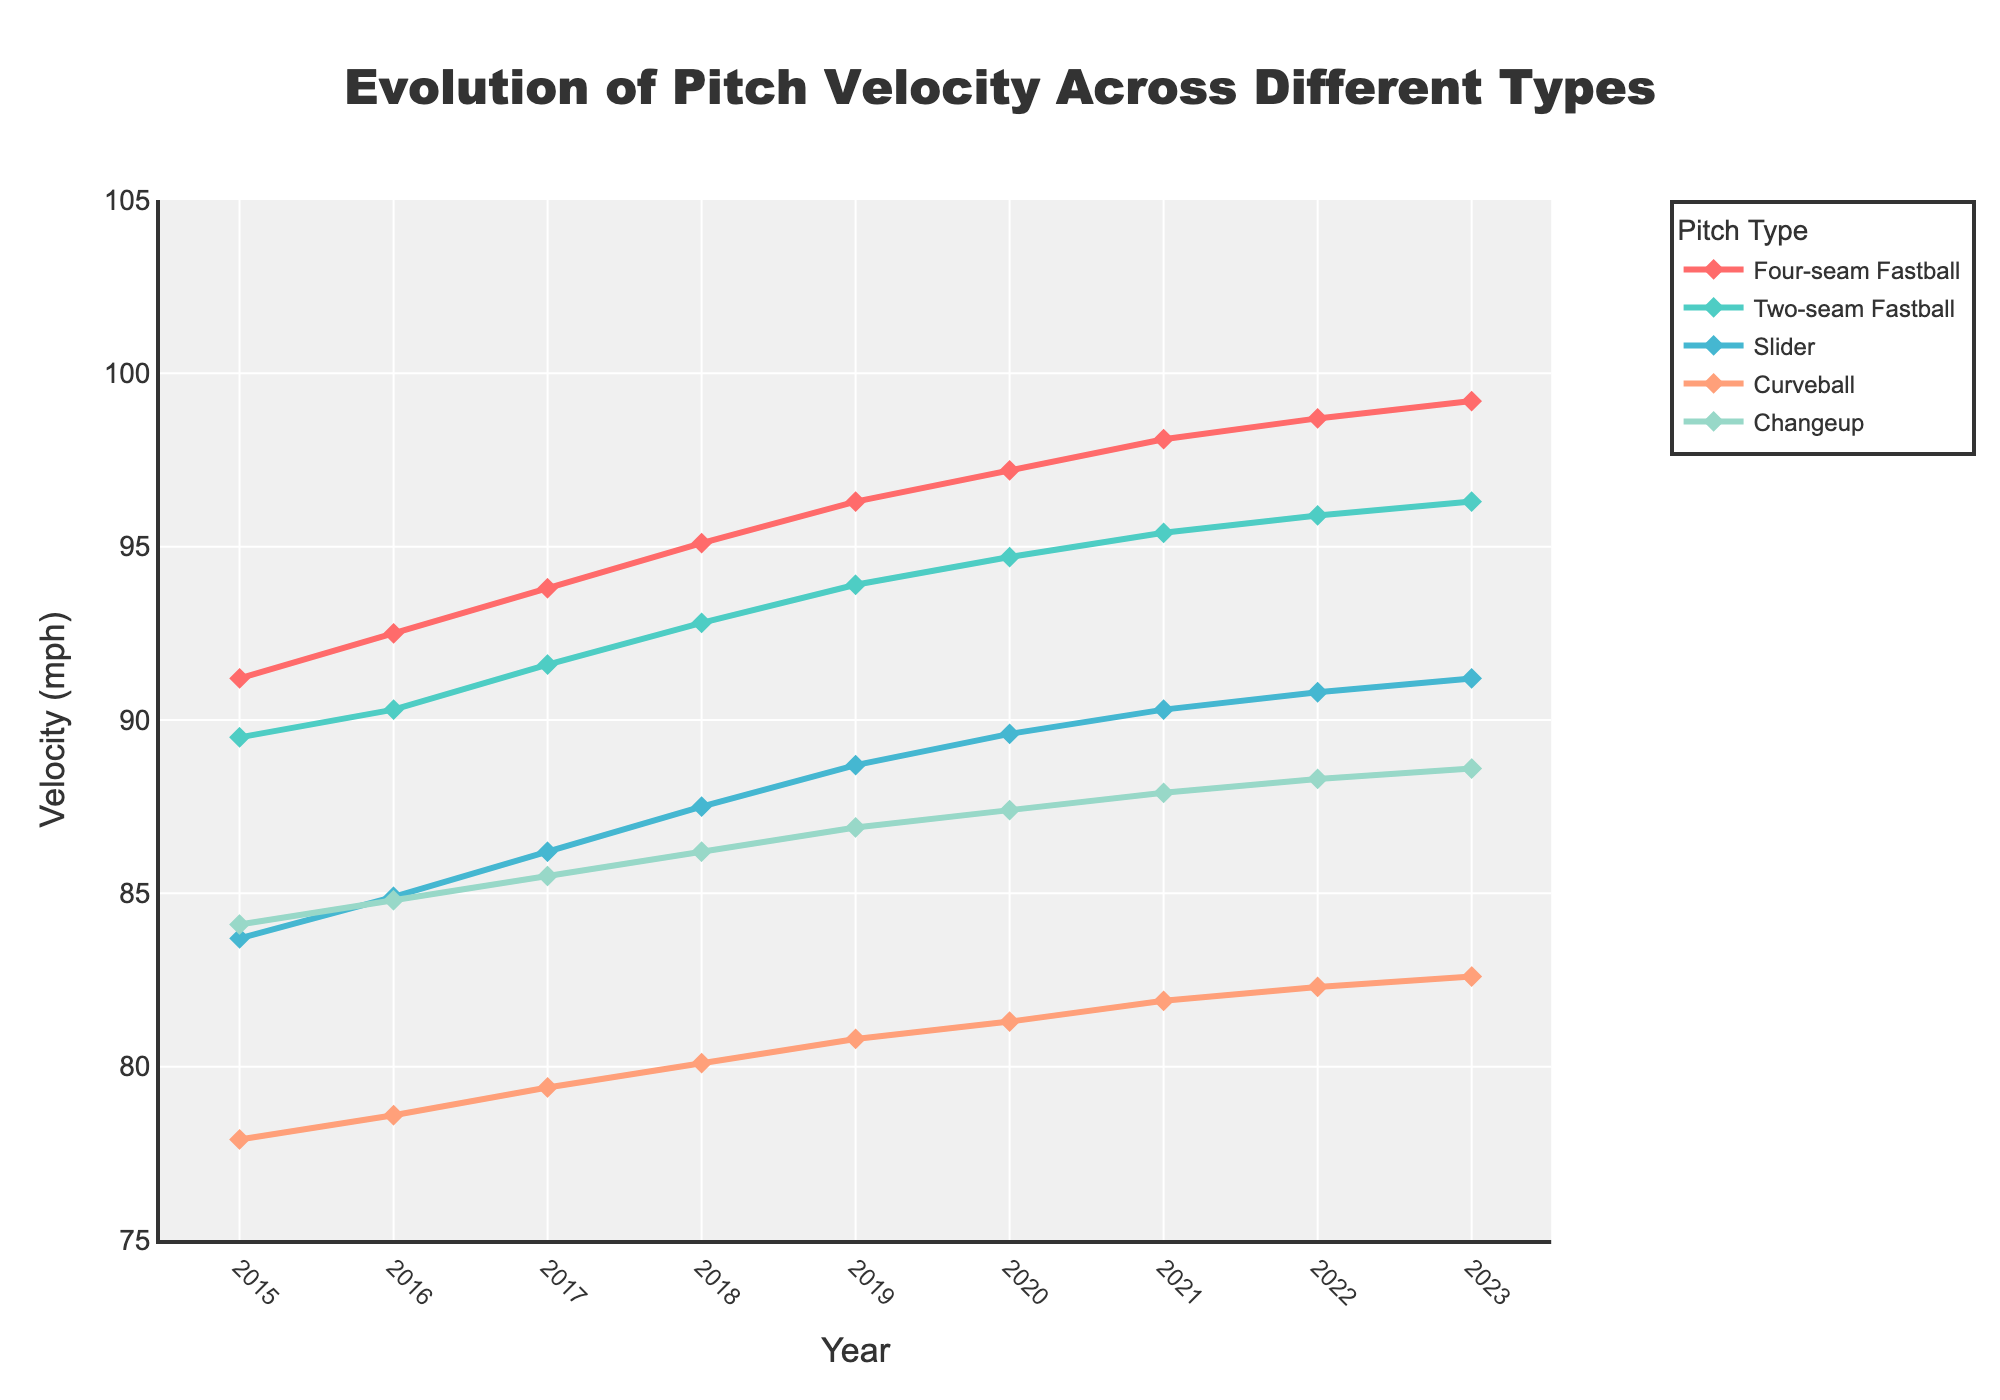What was the velocity of the Four-seam Fastball in 2018? The velocity of the Four-seam Fastball in 2018 can be determined by looking at the data point on the line representing Four-seam Fastball for the year 2018.
Answer: 95.1 mph How did the velocity of the Slider change from 2015 to 2023? To find the change in velocity of the Slider from 2015 to 2023, subtract the Slider's velocity in 2015 from its velocity in 2023: 91.2 mph - 83.7 mph
Answer: Increased by 7.5 mph Which pitch type had the greatest increase in velocity from 2015 to 2023? Calculate the increase for each pitch type by subtracting their 2015 value from their 2023 value. Four-seam Fastball: 99.2 - 91.2 = 8.0 mph, Two-seam Fastball: 96.3 - 89.5 = 6.8 mph, Slider: 91.2 - 83.7 = 7.5 mph, Curveball: 82.6 - 77.9 = 4.7 mph, Changeup: 88.6 - 84.1 = 4.5 mph. The Four-seam Fastball had the highest increase.
Answer: Four-seam Fastball In which year did the Changeup velocity surpass 88 mph for the first time? Examine the data points for Changeup velocity and identify the first year where it exceeds 88 mph. Changeup velocity in 2022 is 88.3 mph.
Answer: 2022 What is the average velocity of the Curveball from 2015 to 2023? Sum up the velocities of the Curveball from 2015 to 2023 and then divide by the number of years: (77.9 + 78.6 + 79.4 + 80.1 + 80.8 + 81.3 + 81.9 + 82.3 + 82.6) / 9
Answer: 80.65 mph Between which two consecutive years did the Four-seam Fastball see the highest increase? Look at the differences in the data points for Four-seam Fastball between consecutive years and find the maximum difference: 2016-2015: 1.3, 2017-2016: 1.3, 2018-2017: 1.3, 2019-2018: 1.2, 2020-2019: 0.9, 2021-2020: 0.9, 2022-2021: 0.6, 2023-2022: 0.5
Answer: 2018-2017 Which pitch type consistently showed the lowest velocity throughout all the years? Identify the pitch type with the lowest values across all years by comparing the data trends in the figure. The Curveball has the lowest velocities throughout.
Answer: Curveball How much did the Two-seam Fastball's velocity increase from 2015 to 2020? Subtract the 2015 velocity of the Two-seam Fastball from its 2020 velocity: 94.7 mph - 89.5 mph
Answer: 5.2 mph Which year had the highest overall average pitch velocity across all types? Calculate the average for each year by summing up all pitch velocities for that year and dividing by 5, then compare the averages. 2023: (99.2 + 96.3 + 91.2 + 82.6 + 88.6) / 5 = 91.58, highest among all years.
Answer: 2023 